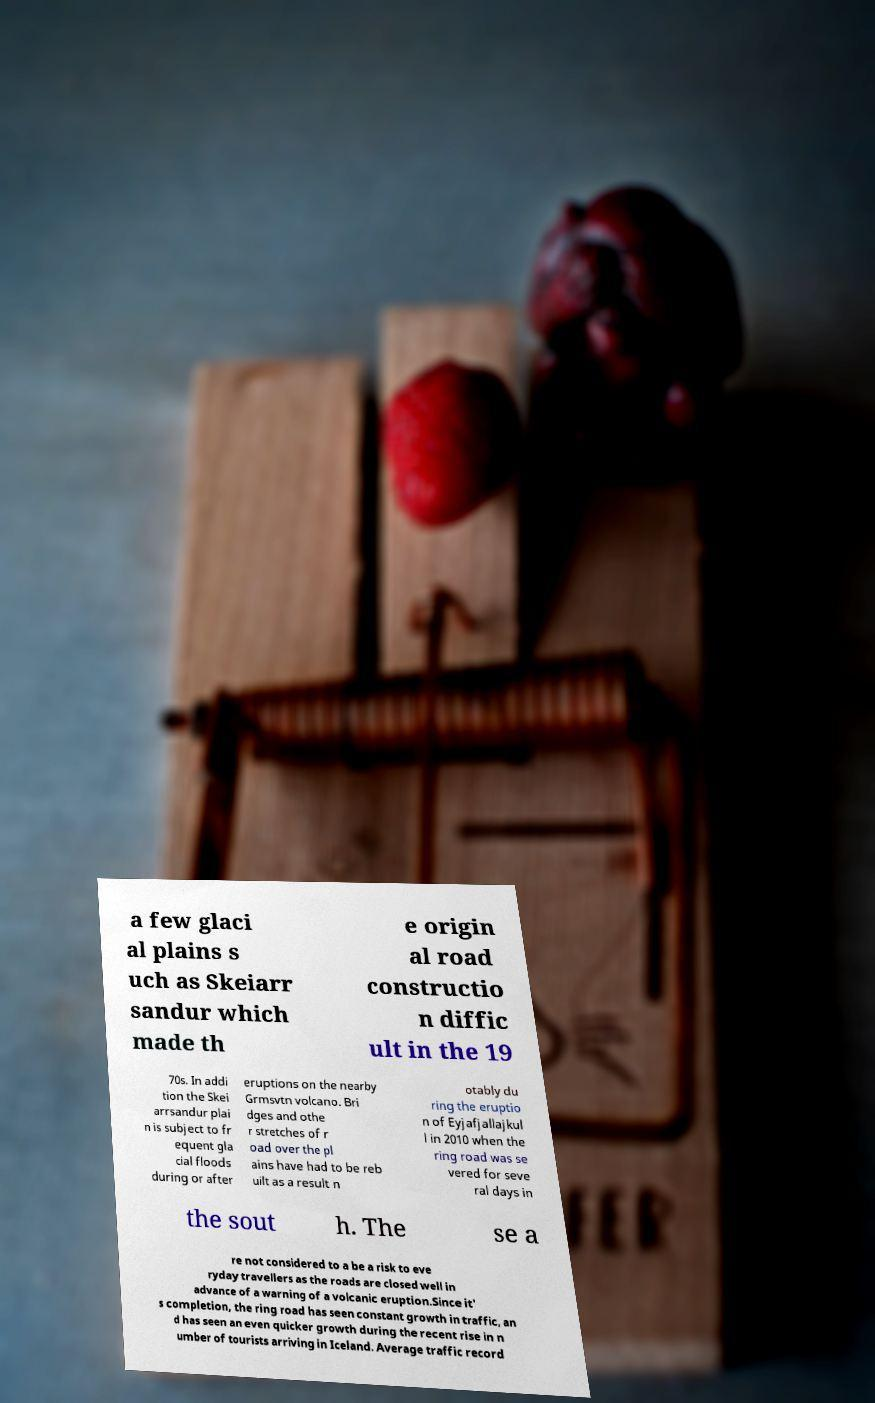Can you accurately transcribe the text from the provided image for me? a few glaci al plains s uch as Skeiarr sandur which made th e origin al road constructio n diffic ult in the 19 70s. In addi tion the Skei arrsandur plai n is subject to fr equent gla cial floods during or after eruptions on the nearby Grmsvtn volcano. Bri dges and othe r stretches of r oad over the pl ains have had to be reb uilt as a result n otably du ring the eruptio n of Eyjafjallajkul l in 2010 when the ring road was se vered for seve ral days in the sout h. The se a re not considered to a be a risk to eve ryday travellers as the roads are closed well in advance of a warning of a volcanic eruption.Since it' s completion, the ring road has seen constant growth in traffic, an d has seen an even quicker growth during the recent rise in n umber of tourists arriving in Iceland. Average traffic record 